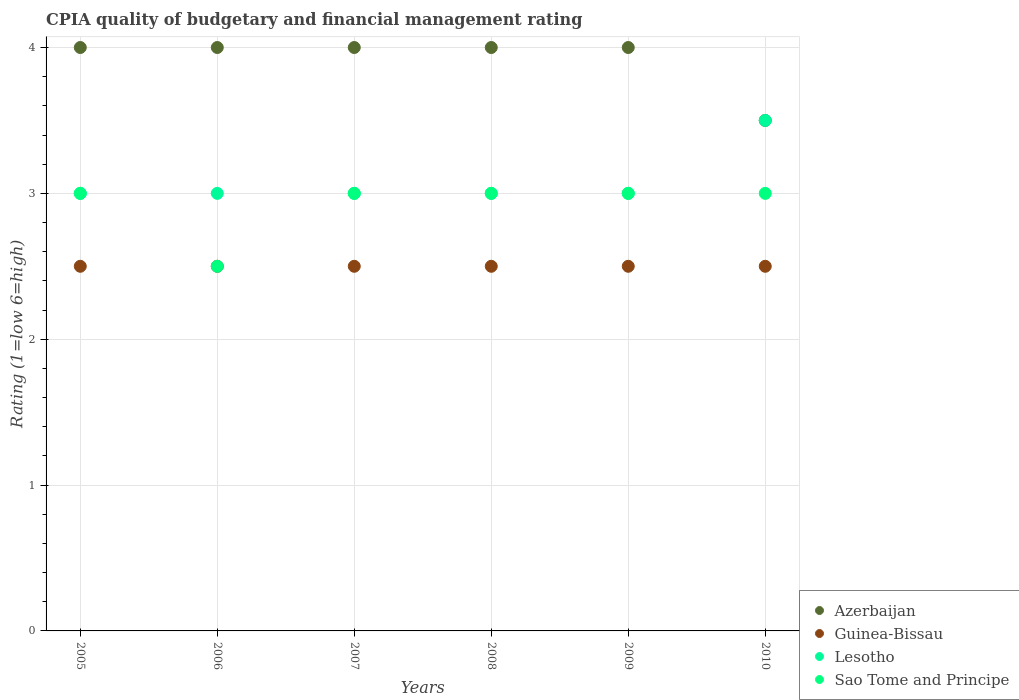How many different coloured dotlines are there?
Keep it short and to the point. 4. Across all years, what is the maximum CPIA rating in Sao Tome and Principe?
Give a very brief answer. 3. Across all years, what is the minimum CPIA rating in Sao Tome and Principe?
Provide a short and direct response. 2.5. In which year was the CPIA rating in Azerbaijan maximum?
Your response must be concise. 2005. In which year was the CPIA rating in Sao Tome and Principe minimum?
Your response must be concise. 2006. What is the difference between the CPIA rating in Azerbaijan in 2010 and the CPIA rating in Guinea-Bissau in 2008?
Your answer should be compact. 1. What is the average CPIA rating in Sao Tome and Principe per year?
Make the answer very short. 2.92. In how many years, is the CPIA rating in Azerbaijan greater than 3.2?
Keep it short and to the point. 6. What is the ratio of the CPIA rating in Lesotho in 2007 to that in 2010?
Offer a terse response. 0.86. Is the CPIA rating in Lesotho in 2007 less than that in 2008?
Offer a very short reply. No. Is the difference between the CPIA rating in Azerbaijan in 2006 and 2008 greater than the difference between the CPIA rating in Guinea-Bissau in 2006 and 2008?
Your response must be concise. No. Is it the case that in every year, the sum of the CPIA rating in Guinea-Bissau and CPIA rating in Azerbaijan  is greater than the sum of CPIA rating in Sao Tome and Principe and CPIA rating in Lesotho?
Your answer should be compact. Yes. Is the CPIA rating in Azerbaijan strictly greater than the CPIA rating in Guinea-Bissau over the years?
Give a very brief answer. Yes. How many dotlines are there?
Provide a short and direct response. 4. Are the values on the major ticks of Y-axis written in scientific E-notation?
Provide a short and direct response. No. Does the graph contain any zero values?
Your response must be concise. No. Does the graph contain grids?
Offer a very short reply. Yes. How many legend labels are there?
Make the answer very short. 4. How are the legend labels stacked?
Your answer should be compact. Vertical. What is the title of the graph?
Ensure brevity in your answer.  CPIA quality of budgetary and financial management rating. Does "Malta" appear as one of the legend labels in the graph?
Offer a very short reply. No. What is the Rating (1=low 6=high) in Azerbaijan in 2005?
Provide a short and direct response. 4. What is the Rating (1=low 6=high) of Sao Tome and Principe in 2005?
Offer a very short reply. 3. What is the Rating (1=low 6=high) of Lesotho in 2006?
Ensure brevity in your answer.  3. What is the Rating (1=low 6=high) of Sao Tome and Principe in 2007?
Your answer should be compact. 3. What is the Rating (1=low 6=high) of Lesotho in 2008?
Make the answer very short. 3. What is the Rating (1=low 6=high) in Sao Tome and Principe in 2008?
Your answer should be very brief. 3. What is the Rating (1=low 6=high) of Lesotho in 2009?
Give a very brief answer. 3. What is the Rating (1=low 6=high) in Guinea-Bissau in 2010?
Make the answer very short. 2.5. What is the Rating (1=low 6=high) of Lesotho in 2010?
Keep it short and to the point. 3.5. Across all years, what is the maximum Rating (1=low 6=high) in Lesotho?
Provide a short and direct response. 3.5. Across all years, what is the minimum Rating (1=low 6=high) of Lesotho?
Your answer should be compact. 3. Across all years, what is the minimum Rating (1=low 6=high) of Sao Tome and Principe?
Your answer should be compact. 2.5. What is the total Rating (1=low 6=high) in Guinea-Bissau in the graph?
Ensure brevity in your answer.  15. What is the total Rating (1=low 6=high) in Lesotho in the graph?
Your answer should be compact. 18.5. What is the total Rating (1=low 6=high) of Sao Tome and Principe in the graph?
Your response must be concise. 17.5. What is the difference between the Rating (1=low 6=high) of Guinea-Bissau in 2005 and that in 2006?
Offer a terse response. 0. What is the difference between the Rating (1=low 6=high) of Lesotho in 2005 and that in 2006?
Ensure brevity in your answer.  0. What is the difference between the Rating (1=low 6=high) in Sao Tome and Principe in 2005 and that in 2006?
Your answer should be very brief. 0.5. What is the difference between the Rating (1=low 6=high) in Azerbaijan in 2005 and that in 2007?
Make the answer very short. 0. What is the difference between the Rating (1=low 6=high) of Azerbaijan in 2005 and that in 2008?
Provide a short and direct response. 0. What is the difference between the Rating (1=low 6=high) of Guinea-Bissau in 2005 and that in 2008?
Make the answer very short. 0. What is the difference between the Rating (1=low 6=high) in Lesotho in 2005 and that in 2008?
Your response must be concise. 0. What is the difference between the Rating (1=low 6=high) in Guinea-Bissau in 2005 and that in 2009?
Your answer should be compact. 0. What is the difference between the Rating (1=low 6=high) in Lesotho in 2005 and that in 2009?
Make the answer very short. 0. What is the difference between the Rating (1=low 6=high) in Guinea-Bissau in 2005 and that in 2010?
Provide a succinct answer. 0. What is the difference between the Rating (1=low 6=high) in Lesotho in 2005 and that in 2010?
Your answer should be compact. -0.5. What is the difference between the Rating (1=low 6=high) of Sao Tome and Principe in 2005 and that in 2010?
Offer a terse response. 0. What is the difference between the Rating (1=low 6=high) in Lesotho in 2006 and that in 2007?
Your response must be concise. 0. What is the difference between the Rating (1=low 6=high) in Sao Tome and Principe in 2006 and that in 2007?
Give a very brief answer. -0.5. What is the difference between the Rating (1=low 6=high) of Azerbaijan in 2006 and that in 2008?
Give a very brief answer. 0. What is the difference between the Rating (1=low 6=high) of Sao Tome and Principe in 2006 and that in 2008?
Your response must be concise. -0.5. What is the difference between the Rating (1=low 6=high) of Lesotho in 2006 and that in 2009?
Offer a terse response. 0. What is the difference between the Rating (1=low 6=high) of Lesotho in 2006 and that in 2010?
Keep it short and to the point. -0.5. What is the difference between the Rating (1=low 6=high) of Azerbaijan in 2007 and that in 2008?
Ensure brevity in your answer.  0. What is the difference between the Rating (1=low 6=high) of Lesotho in 2007 and that in 2009?
Ensure brevity in your answer.  0. What is the difference between the Rating (1=low 6=high) of Sao Tome and Principe in 2007 and that in 2009?
Provide a short and direct response. 0. What is the difference between the Rating (1=low 6=high) of Guinea-Bissau in 2007 and that in 2010?
Offer a terse response. 0. What is the difference between the Rating (1=low 6=high) of Lesotho in 2007 and that in 2010?
Keep it short and to the point. -0.5. What is the difference between the Rating (1=low 6=high) in Lesotho in 2008 and that in 2009?
Keep it short and to the point. 0. What is the difference between the Rating (1=low 6=high) in Sao Tome and Principe in 2008 and that in 2009?
Your answer should be compact. 0. What is the difference between the Rating (1=low 6=high) of Azerbaijan in 2008 and that in 2010?
Your answer should be very brief. 0.5. What is the difference between the Rating (1=low 6=high) in Sao Tome and Principe in 2008 and that in 2010?
Ensure brevity in your answer.  0. What is the difference between the Rating (1=low 6=high) of Azerbaijan in 2009 and that in 2010?
Give a very brief answer. 0.5. What is the difference between the Rating (1=low 6=high) in Guinea-Bissau in 2009 and that in 2010?
Make the answer very short. 0. What is the difference between the Rating (1=low 6=high) in Lesotho in 2009 and that in 2010?
Provide a short and direct response. -0.5. What is the difference between the Rating (1=low 6=high) in Sao Tome and Principe in 2009 and that in 2010?
Keep it short and to the point. 0. What is the difference between the Rating (1=low 6=high) of Azerbaijan in 2005 and the Rating (1=low 6=high) of Guinea-Bissau in 2006?
Make the answer very short. 1.5. What is the difference between the Rating (1=low 6=high) of Azerbaijan in 2005 and the Rating (1=low 6=high) of Sao Tome and Principe in 2006?
Offer a terse response. 1.5. What is the difference between the Rating (1=low 6=high) in Guinea-Bissau in 2005 and the Rating (1=low 6=high) in Sao Tome and Principe in 2006?
Make the answer very short. 0. What is the difference between the Rating (1=low 6=high) of Guinea-Bissau in 2005 and the Rating (1=low 6=high) of Lesotho in 2007?
Make the answer very short. -0.5. What is the difference between the Rating (1=low 6=high) in Guinea-Bissau in 2005 and the Rating (1=low 6=high) in Sao Tome and Principe in 2007?
Ensure brevity in your answer.  -0.5. What is the difference between the Rating (1=low 6=high) of Lesotho in 2005 and the Rating (1=low 6=high) of Sao Tome and Principe in 2007?
Your response must be concise. 0. What is the difference between the Rating (1=low 6=high) in Azerbaijan in 2005 and the Rating (1=low 6=high) in Guinea-Bissau in 2008?
Keep it short and to the point. 1.5. What is the difference between the Rating (1=low 6=high) of Azerbaijan in 2005 and the Rating (1=low 6=high) of Sao Tome and Principe in 2008?
Offer a very short reply. 1. What is the difference between the Rating (1=low 6=high) of Guinea-Bissau in 2005 and the Rating (1=low 6=high) of Lesotho in 2008?
Make the answer very short. -0.5. What is the difference between the Rating (1=low 6=high) in Guinea-Bissau in 2005 and the Rating (1=low 6=high) in Sao Tome and Principe in 2008?
Provide a short and direct response. -0.5. What is the difference between the Rating (1=low 6=high) of Azerbaijan in 2005 and the Rating (1=low 6=high) of Guinea-Bissau in 2009?
Your answer should be compact. 1.5. What is the difference between the Rating (1=low 6=high) of Azerbaijan in 2005 and the Rating (1=low 6=high) of Lesotho in 2009?
Make the answer very short. 1. What is the difference between the Rating (1=low 6=high) of Azerbaijan in 2005 and the Rating (1=low 6=high) of Sao Tome and Principe in 2009?
Give a very brief answer. 1. What is the difference between the Rating (1=low 6=high) in Azerbaijan in 2005 and the Rating (1=low 6=high) in Guinea-Bissau in 2010?
Offer a very short reply. 1.5. What is the difference between the Rating (1=low 6=high) of Azerbaijan in 2005 and the Rating (1=low 6=high) of Lesotho in 2010?
Your answer should be compact. 0.5. What is the difference between the Rating (1=low 6=high) of Guinea-Bissau in 2005 and the Rating (1=low 6=high) of Sao Tome and Principe in 2010?
Make the answer very short. -0.5. What is the difference between the Rating (1=low 6=high) in Azerbaijan in 2006 and the Rating (1=low 6=high) in Guinea-Bissau in 2007?
Your answer should be very brief. 1.5. What is the difference between the Rating (1=low 6=high) of Azerbaijan in 2006 and the Rating (1=low 6=high) of Lesotho in 2007?
Your answer should be compact. 1. What is the difference between the Rating (1=low 6=high) of Guinea-Bissau in 2006 and the Rating (1=low 6=high) of Sao Tome and Principe in 2007?
Provide a short and direct response. -0.5. What is the difference between the Rating (1=low 6=high) of Azerbaijan in 2006 and the Rating (1=low 6=high) of Lesotho in 2008?
Make the answer very short. 1. What is the difference between the Rating (1=low 6=high) of Azerbaijan in 2006 and the Rating (1=low 6=high) of Sao Tome and Principe in 2008?
Your response must be concise. 1. What is the difference between the Rating (1=low 6=high) in Guinea-Bissau in 2006 and the Rating (1=low 6=high) in Lesotho in 2008?
Keep it short and to the point. -0.5. What is the difference between the Rating (1=low 6=high) in Guinea-Bissau in 2006 and the Rating (1=low 6=high) in Sao Tome and Principe in 2009?
Provide a short and direct response. -0.5. What is the difference between the Rating (1=low 6=high) in Lesotho in 2006 and the Rating (1=low 6=high) in Sao Tome and Principe in 2009?
Provide a short and direct response. 0. What is the difference between the Rating (1=low 6=high) in Azerbaijan in 2006 and the Rating (1=low 6=high) in Lesotho in 2010?
Give a very brief answer. 0.5. What is the difference between the Rating (1=low 6=high) of Azerbaijan in 2006 and the Rating (1=low 6=high) of Sao Tome and Principe in 2010?
Your response must be concise. 1. What is the difference between the Rating (1=low 6=high) of Guinea-Bissau in 2006 and the Rating (1=low 6=high) of Lesotho in 2010?
Make the answer very short. -1. What is the difference between the Rating (1=low 6=high) in Guinea-Bissau in 2006 and the Rating (1=low 6=high) in Sao Tome and Principe in 2010?
Offer a very short reply. -0.5. What is the difference between the Rating (1=low 6=high) in Lesotho in 2006 and the Rating (1=low 6=high) in Sao Tome and Principe in 2010?
Provide a short and direct response. 0. What is the difference between the Rating (1=low 6=high) of Azerbaijan in 2007 and the Rating (1=low 6=high) of Guinea-Bissau in 2008?
Provide a succinct answer. 1.5. What is the difference between the Rating (1=low 6=high) in Azerbaijan in 2007 and the Rating (1=low 6=high) in Lesotho in 2008?
Your answer should be compact. 1. What is the difference between the Rating (1=low 6=high) of Guinea-Bissau in 2007 and the Rating (1=low 6=high) of Lesotho in 2008?
Keep it short and to the point. -0.5. What is the difference between the Rating (1=low 6=high) of Lesotho in 2007 and the Rating (1=low 6=high) of Sao Tome and Principe in 2008?
Your answer should be compact. 0. What is the difference between the Rating (1=low 6=high) of Azerbaijan in 2007 and the Rating (1=low 6=high) of Guinea-Bissau in 2009?
Provide a short and direct response. 1.5. What is the difference between the Rating (1=low 6=high) of Azerbaijan in 2007 and the Rating (1=low 6=high) of Lesotho in 2009?
Offer a terse response. 1. What is the difference between the Rating (1=low 6=high) in Guinea-Bissau in 2007 and the Rating (1=low 6=high) in Lesotho in 2009?
Offer a terse response. -0.5. What is the difference between the Rating (1=low 6=high) of Lesotho in 2007 and the Rating (1=low 6=high) of Sao Tome and Principe in 2009?
Offer a terse response. 0. What is the difference between the Rating (1=low 6=high) in Guinea-Bissau in 2007 and the Rating (1=low 6=high) in Sao Tome and Principe in 2010?
Make the answer very short. -0.5. What is the difference between the Rating (1=low 6=high) of Azerbaijan in 2008 and the Rating (1=low 6=high) of Lesotho in 2009?
Offer a terse response. 1. What is the difference between the Rating (1=low 6=high) of Lesotho in 2008 and the Rating (1=low 6=high) of Sao Tome and Principe in 2009?
Offer a very short reply. 0. What is the difference between the Rating (1=low 6=high) of Guinea-Bissau in 2008 and the Rating (1=low 6=high) of Sao Tome and Principe in 2010?
Your answer should be compact. -0.5. What is the difference between the Rating (1=low 6=high) of Lesotho in 2008 and the Rating (1=low 6=high) of Sao Tome and Principe in 2010?
Provide a succinct answer. 0. What is the difference between the Rating (1=low 6=high) in Azerbaijan in 2009 and the Rating (1=low 6=high) in Lesotho in 2010?
Ensure brevity in your answer.  0.5. What is the average Rating (1=low 6=high) of Azerbaijan per year?
Your answer should be very brief. 3.92. What is the average Rating (1=low 6=high) in Guinea-Bissau per year?
Your response must be concise. 2.5. What is the average Rating (1=low 6=high) in Lesotho per year?
Offer a terse response. 3.08. What is the average Rating (1=low 6=high) in Sao Tome and Principe per year?
Provide a succinct answer. 2.92. In the year 2005, what is the difference between the Rating (1=low 6=high) in Azerbaijan and Rating (1=low 6=high) in Lesotho?
Your answer should be compact. 1. In the year 2005, what is the difference between the Rating (1=low 6=high) in Guinea-Bissau and Rating (1=low 6=high) in Sao Tome and Principe?
Give a very brief answer. -0.5. In the year 2006, what is the difference between the Rating (1=low 6=high) in Azerbaijan and Rating (1=low 6=high) in Lesotho?
Keep it short and to the point. 1. In the year 2006, what is the difference between the Rating (1=low 6=high) of Guinea-Bissau and Rating (1=low 6=high) of Sao Tome and Principe?
Provide a short and direct response. 0. In the year 2007, what is the difference between the Rating (1=low 6=high) in Azerbaijan and Rating (1=low 6=high) in Lesotho?
Provide a succinct answer. 1. In the year 2007, what is the difference between the Rating (1=low 6=high) of Azerbaijan and Rating (1=low 6=high) of Sao Tome and Principe?
Give a very brief answer. 1. In the year 2007, what is the difference between the Rating (1=low 6=high) of Guinea-Bissau and Rating (1=low 6=high) of Sao Tome and Principe?
Offer a terse response. -0.5. In the year 2007, what is the difference between the Rating (1=low 6=high) of Lesotho and Rating (1=low 6=high) of Sao Tome and Principe?
Provide a short and direct response. 0. In the year 2008, what is the difference between the Rating (1=low 6=high) in Azerbaijan and Rating (1=low 6=high) in Lesotho?
Your answer should be compact. 1. In the year 2008, what is the difference between the Rating (1=low 6=high) in Guinea-Bissau and Rating (1=low 6=high) in Sao Tome and Principe?
Your answer should be compact. -0.5. In the year 2008, what is the difference between the Rating (1=low 6=high) in Lesotho and Rating (1=low 6=high) in Sao Tome and Principe?
Offer a terse response. 0. In the year 2009, what is the difference between the Rating (1=low 6=high) in Guinea-Bissau and Rating (1=low 6=high) in Sao Tome and Principe?
Give a very brief answer. -0.5. In the year 2009, what is the difference between the Rating (1=low 6=high) of Lesotho and Rating (1=low 6=high) of Sao Tome and Principe?
Provide a succinct answer. 0. In the year 2010, what is the difference between the Rating (1=low 6=high) of Guinea-Bissau and Rating (1=low 6=high) of Sao Tome and Principe?
Provide a succinct answer. -0.5. In the year 2010, what is the difference between the Rating (1=low 6=high) in Lesotho and Rating (1=low 6=high) in Sao Tome and Principe?
Offer a terse response. 0.5. What is the ratio of the Rating (1=low 6=high) in Guinea-Bissau in 2005 to that in 2006?
Your answer should be compact. 1. What is the ratio of the Rating (1=low 6=high) of Lesotho in 2005 to that in 2006?
Offer a very short reply. 1. What is the ratio of the Rating (1=low 6=high) in Guinea-Bissau in 2005 to that in 2007?
Provide a short and direct response. 1. What is the ratio of the Rating (1=low 6=high) of Lesotho in 2005 to that in 2007?
Make the answer very short. 1. What is the ratio of the Rating (1=low 6=high) of Sao Tome and Principe in 2005 to that in 2007?
Offer a terse response. 1. What is the ratio of the Rating (1=low 6=high) in Guinea-Bissau in 2005 to that in 2008?
Give a very brief answer. 1. What is the ratio of the Rating (1=low 6=high) in Lesotho in 2005 to that in 2008?
Offer a terse response. 1. What is the ratio of the Rating (1=low 6=high) in Guinea-Bissau in 2005 to that in 2009?
Give a very brief answer. 1. What is the ratio of the Rating (1=low 6=high) in Lesotho in 2005 to that in 2009?
Give a very brief answer. 1. What is the ratio of the Rating (1=low 6=high) of Azerbaijan in 2005 to that in 2010?
Your answer should be compact. 1.14. What is the ratio of the Rating (1=low 6=high) of Lesotho in 2006 to that in 2007?
Keep it short and to the point. 1. What is the ratio of the Rating (1=low 6=high) in Sao Tome and Principe in 2006 to that in 2007?
Give a very brief answer. 0.83. What is the ratio of the Rating (1=low 6=high) of Azerbaijan in 2006 to that in 2008?
Ensure brevity in your answer.  1. What is the ratio of the Rating (1=low 6=high) of Azerbaijan in 2006 to that in 2009?
Your response must be concise. 1. What is the ratio of the Rating (1=low 6=high) in Lesotho in 2006 to that in 2009?
Offer a very short reply. 1. What is the ratio of the Rating (1=low 6=high) of Sao Tome and Principe in 2006 to that in 2009?
Your response must be concise. 0.83. What is the ratio of the Rating (1=low 6=high) of Azerbaijan in 2006 to that in 2010?
Provide a short and direct response. 1.14. What is the ratio of the Rating (1=low 6=high) in Guinea-Bissau in 2006 to that in 2010?
Ensure brevity in your answer.  1. What is the ratio of the Rating (1=low 6=high) of Sao Tome and Principe in 2006 to that in 2010?
Provide a short and direct response. 0.83. What is the ratio of the Rating (1=low 6=high) in Lesotho in 2007 to that in 2008?
Your answer should be compact. 1. What is the ratio of the Rating (1=low 6=high) in Lesotho in 2007 to that in 2010?
Provide a short and direct response. 0.86. What is the ratio of the Rating (1=low 6=high) of Sao Tome and Principe in 2007 to that in 2010?
Make the answer very short. 1. What is the ratio of the Rating (1=low 6=high) of Guinea-Bissau in 2008 to that in 2010?
Your answer should be compact. 1. What is the ratio of the Rating (1=low 6=high) in Sao Tome and Principe in 2008 to that in 2010?
Offer a very short reply. 1. What is the ratio of the Rating (1=low 6=high) in Azerbaijan in 2009 to that in 2010?
Your answer should be very brief. 1.14. What is the ratio of the Rating (1=low 6=high) of Guinea-Bissau in 2009 to that in 2010?
Your answer should be compact. 1. What is the ratio of the Rating (1=low 6=high) in Sao Tome and Principe in 2009 to that in 2010?
Provide a short and direct response. 1. What is the difference between the highest and the second highest Rating (1=low 6=high) of Azerbaijan?
Offer a very short reply. 0. What is the difference between the highest and the second highest Rating (1=low 6=high) of Guinea-Bissau?
Provide a short and direct response. 0. What is the difference between the highest and the second highest Rating (1=low 6=high) in Sao Tome and Principe?
Ensure brevity in your answer.  0. What is the difference between the highest and the lowest Rating (1=low 6=high) of Guinea-Bissau?
Keep it short and to the point. 0. What is the difference between the highest and the lowest Rating (1=low 6=high) in Lesotho?
Provide a succinct answer. 0.5. What is the difference between the highest and the lowest Rating (1=low 6=high) of Sao Tome and Principe?
Offer a very short reply. 0.5. 